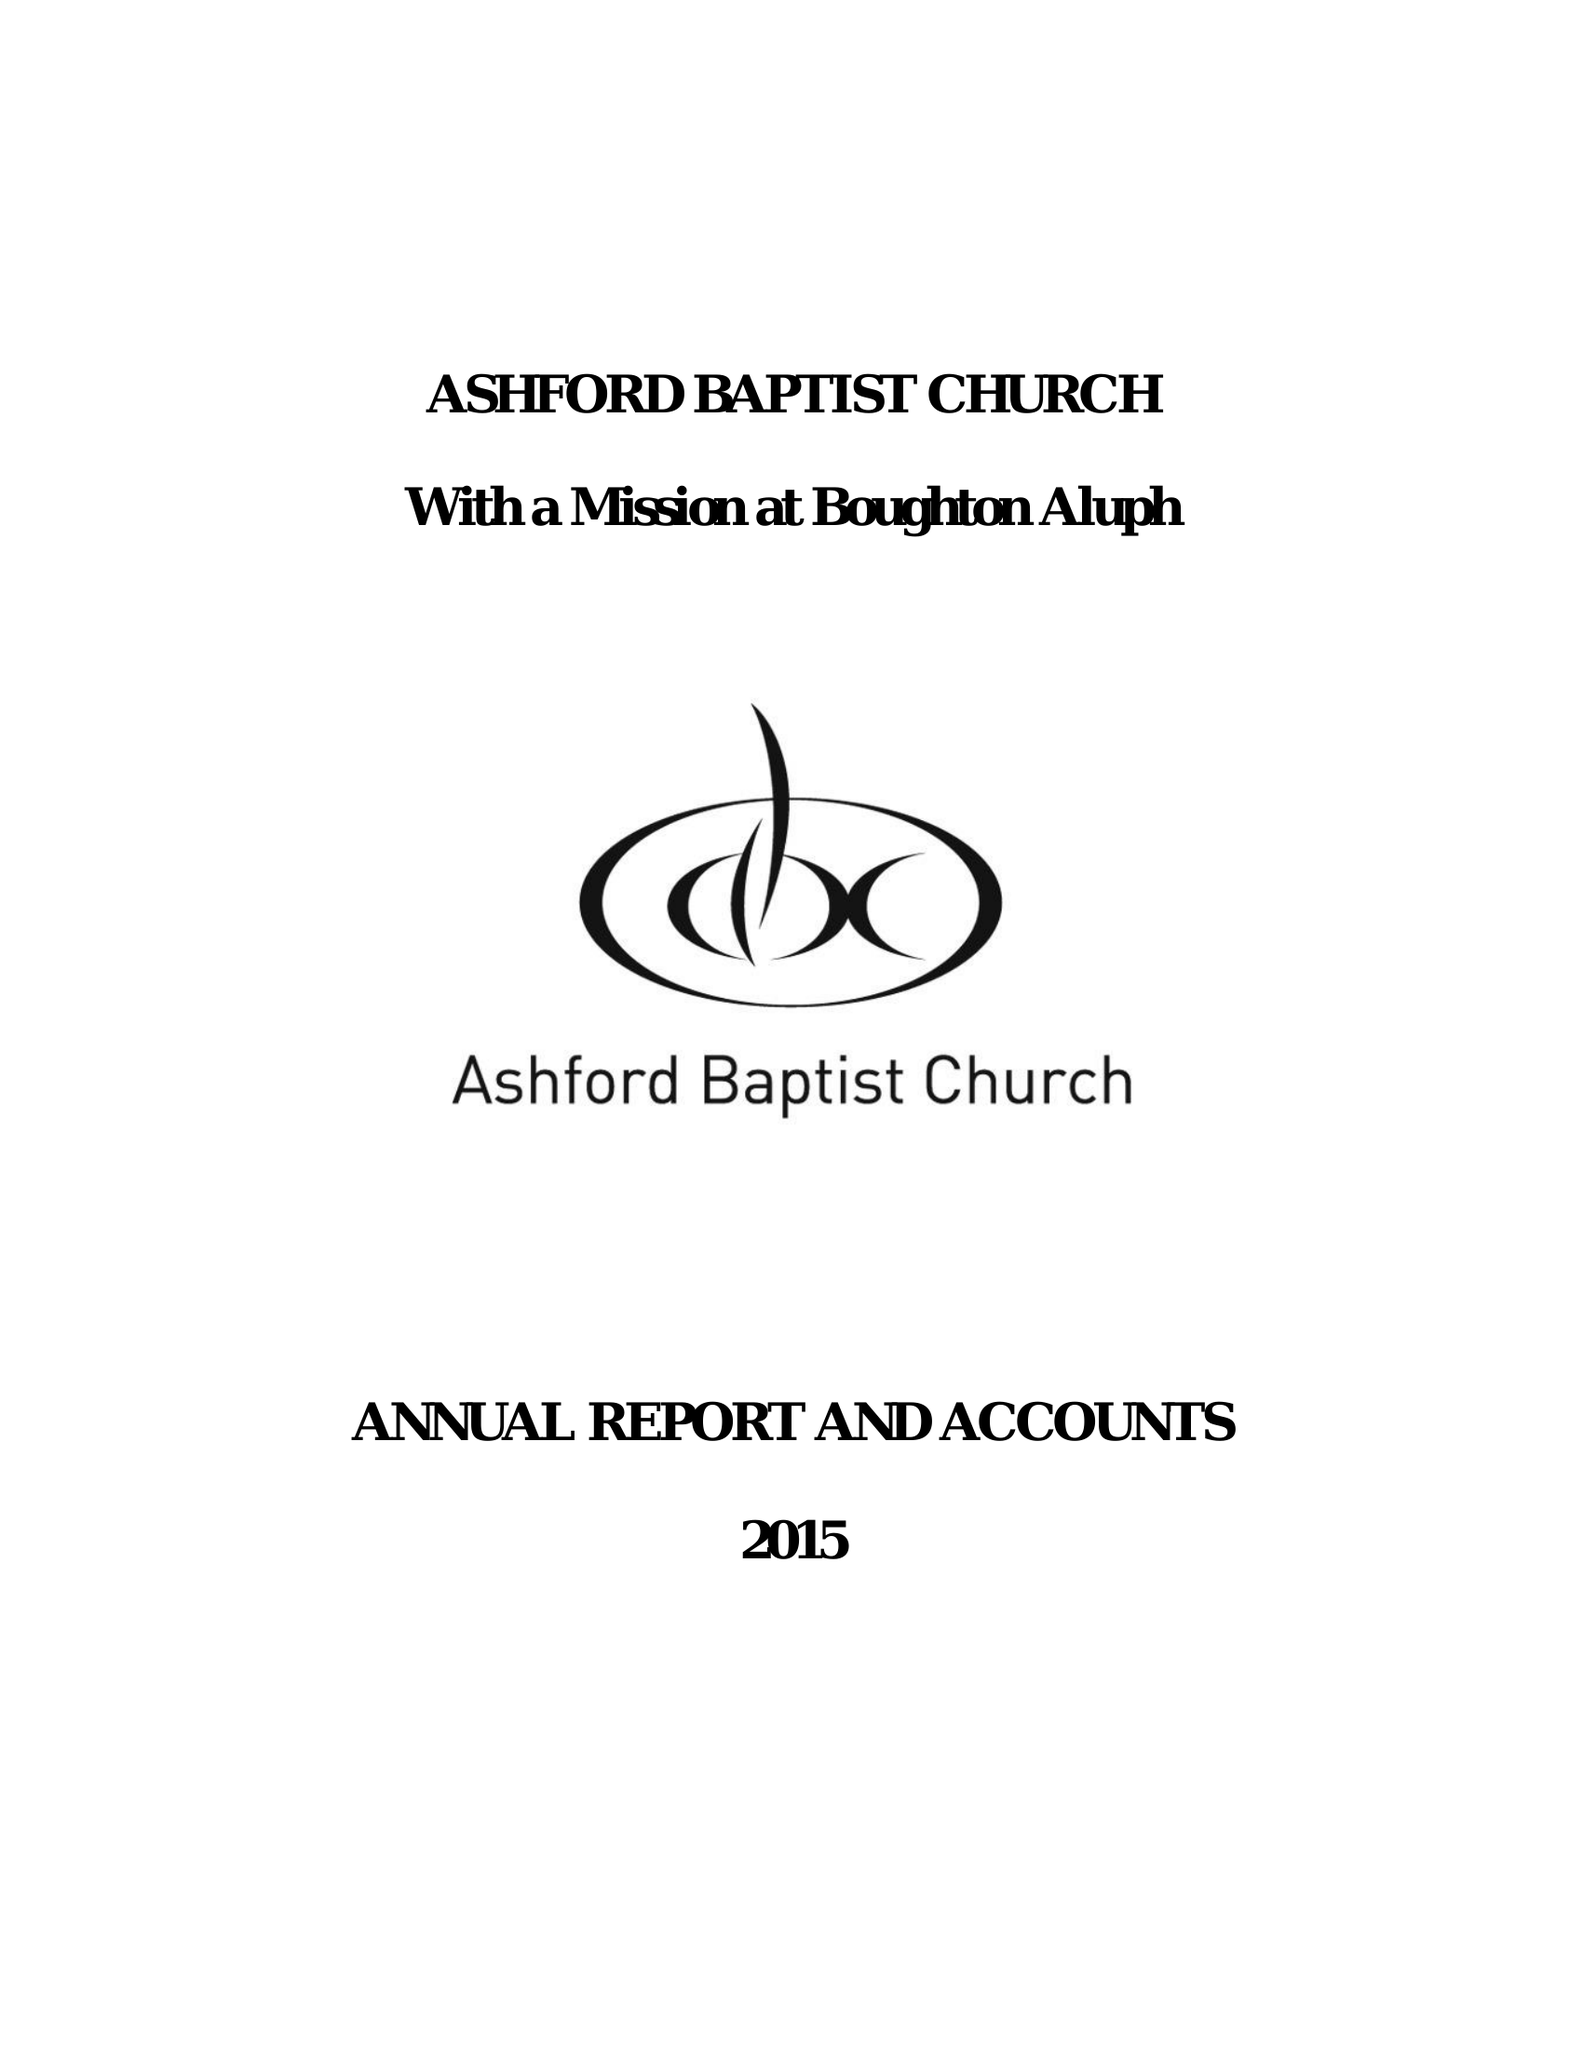What is the value for the report_date?
Answer the question using a single word or phrase. 2015-12-31 